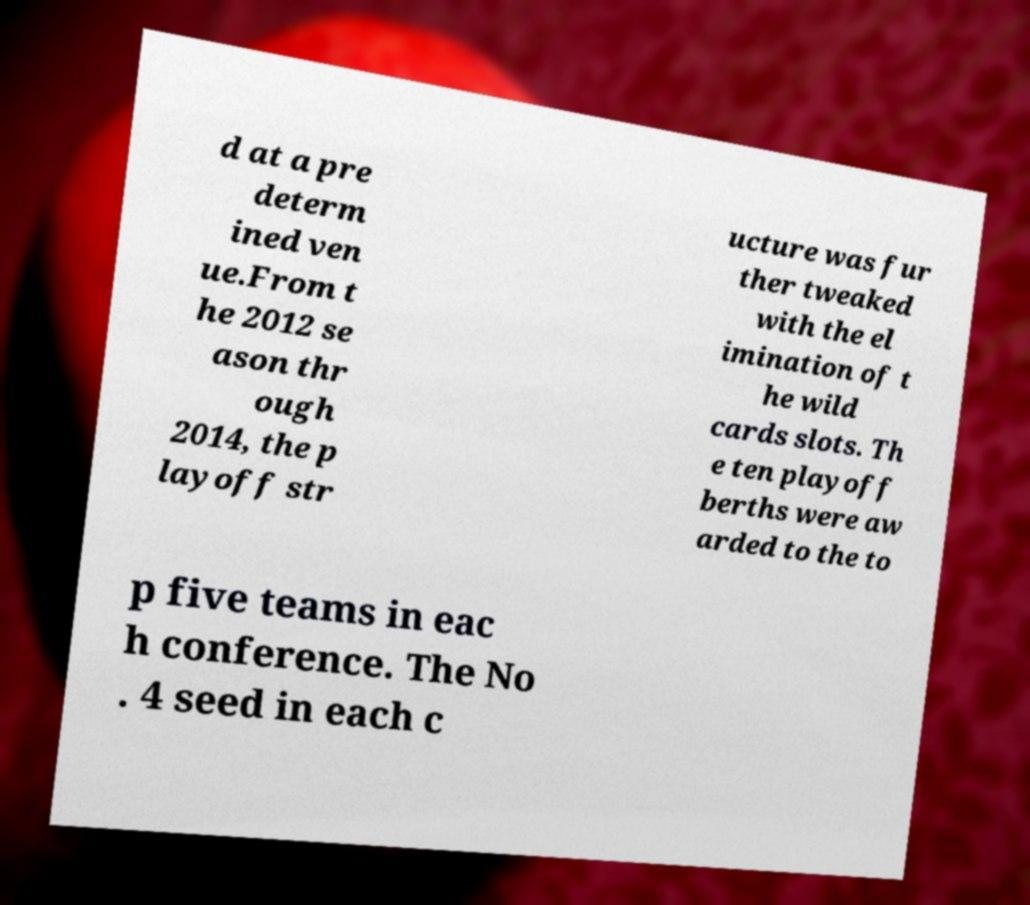What messages or text are displayed in this image? I need them in a readable, typed format. d at a pre determ ined ven ue.From t he 2012 se ason thr ough 2014, the p layoff str ucture was fur ther tweaked with the el imination of t he wild cards slots. Th e ten playoff berths were aw arded to the to p five teams in eac h conference. The No . 4 seed in each c 